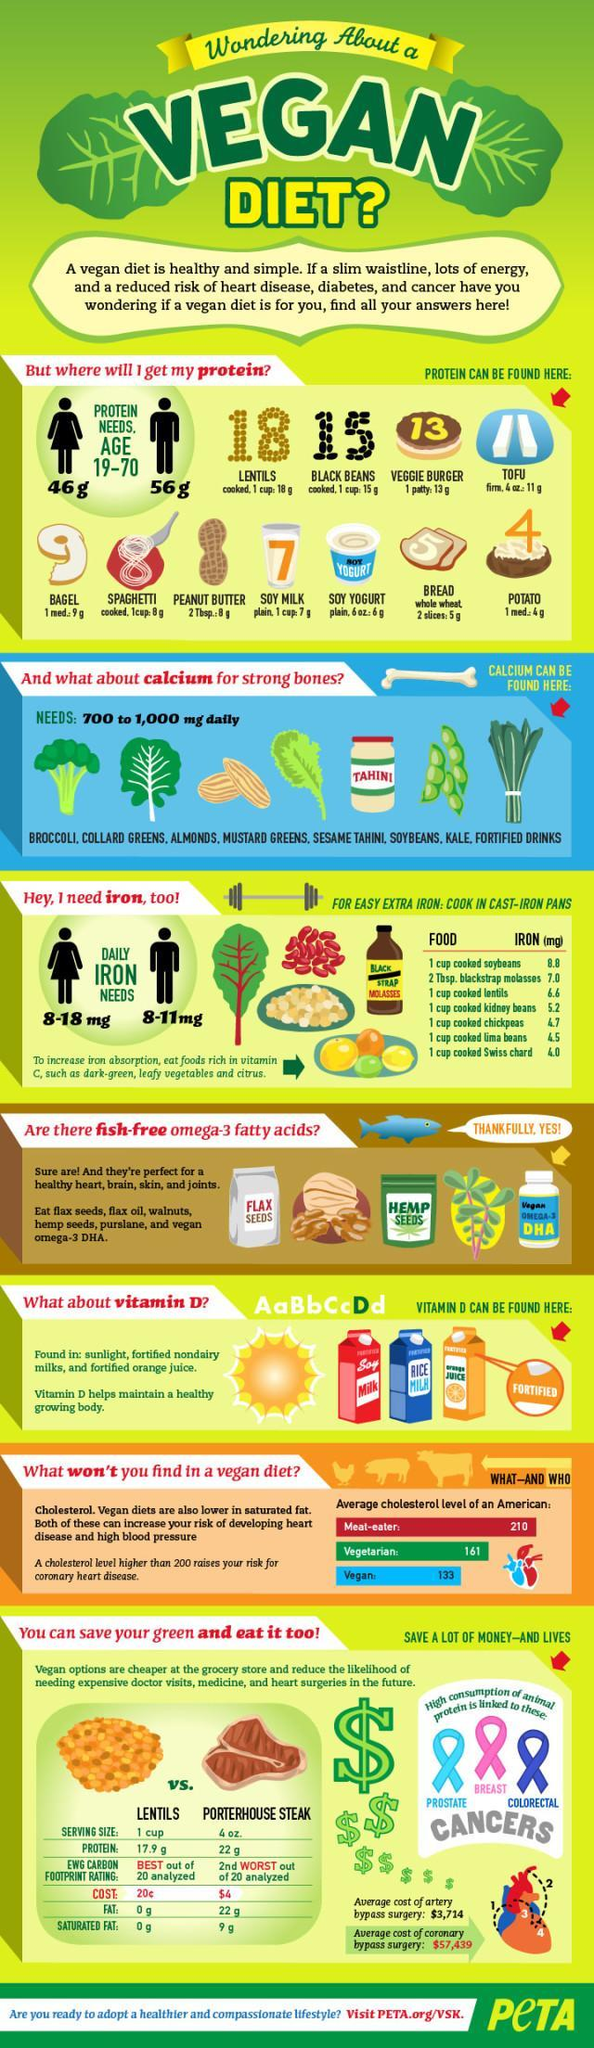How many items are listed that can be taken instead of fish omega-3 fastty acids?
Answer the question with a short phrase. 6 What amount of protein does an adult woman need? 46 g Which element will be provided by Swiss chard? IRON Which food item listed provides the highest amount of protein? LENTILS How much calcium do you need everyday? 700 to 1,000 mg Which group of Americans has the least average cholesterol level? Vegan 